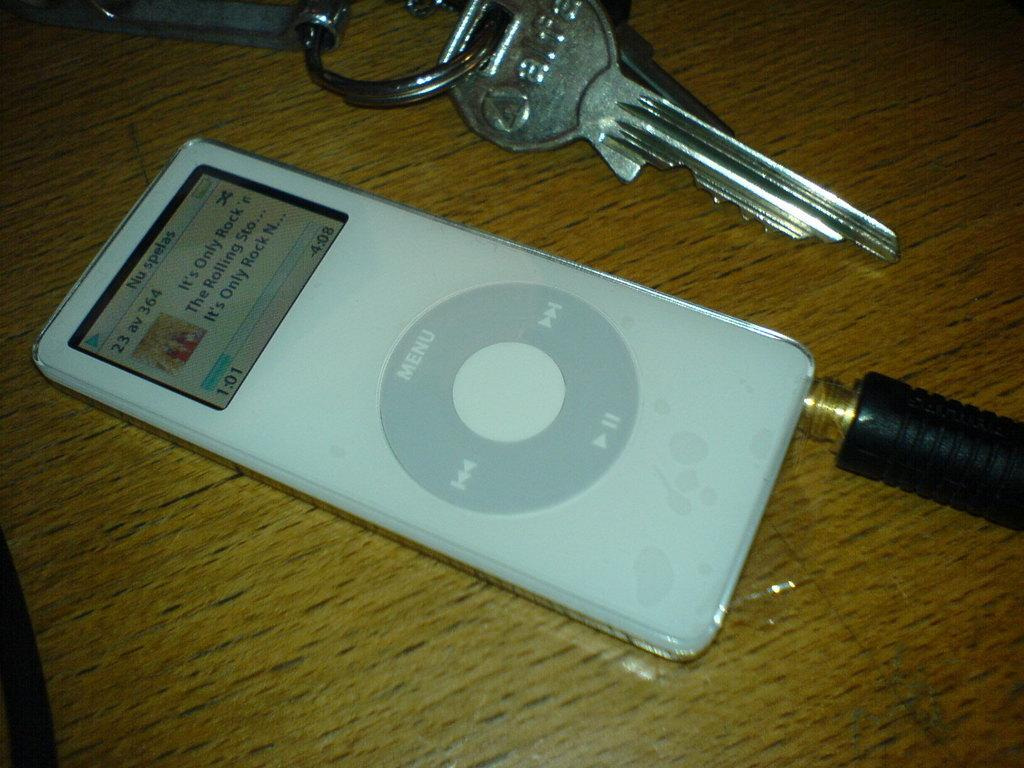What type of device is visible in the image? There is a device with a screen in the image. Where is the device located? The device is placed on a table. What can be seen at the top of the image? There are keys visible at the top of the image. What surprise does the daughter have for her hearing-impaired friend in the image? There is no daughter or friend present in the image, and no surprise or hearing-impaired context is mentioned. 